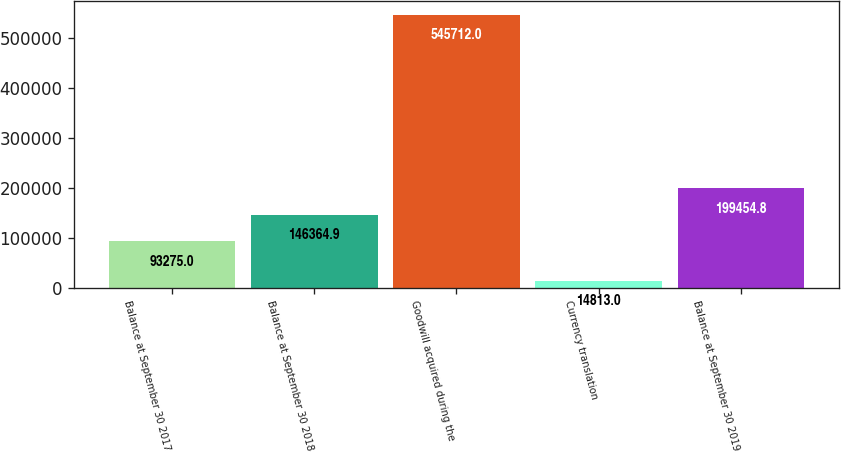<chart> <loc_0><loc_0><loc_500><loc_500><bar_chart><fcel>Balance at September 30 2017<fcel>Balance at September 30 2018<fcel>Goodwill acquired during the<fcel>Currency translation<fcel>Balance at September 30 2019<nl><fcel>93275<fcel>146365<fcel>545712<fcel>14813<fcel>199455<nl></chart> 